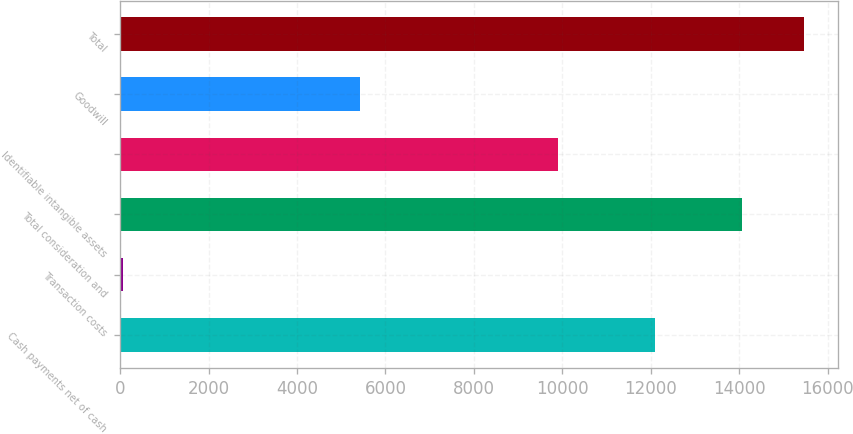<chart> <loc_0><loc_0><loc_500><loc_500><bar_chart><fcel>Cash payments net of cash<fcel>Transaction costs<fcel>Total consideration and<fcel>Identifiable intangible assets<fcel>Goodwill<fcel>Total<nl><fcel>12100<fcel>69<fcel>14069<fcel>9900<fcel>5427<fcel>15469<nl></chart> 